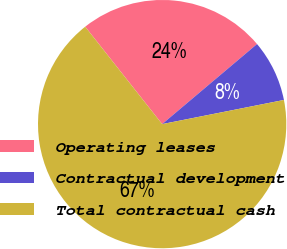<chart> <loc_0><loc_0><loc_500><loc_500><pie_chart><fcel>Operating leases<fcel>Contractual development<fcel>Total contractual cash<nl><fcel>24.49%<fcel>8.04%<fcel>67.48%<nl></chart> 